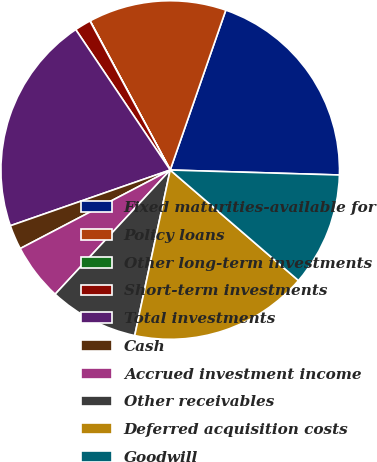Convert chart to OTSL. <chart><loc_0><loc_0><loc_500><loc_500><pie_chart><fcel>Fixed maturities-available for<fcel>Policy loans<fcel>Other long-term investments<fcel>Short-term investments<fcel>Total investments<fcel>Cash<fcel>Accrued investment income<fcel>Other receivables<fcel>Deferred acquisition costs<fcel>Goodwill<nl><fcel>20.14%<fcel>13.17%<fcel>0.02%<fcel>1.56%<fcel>20.91%<fcel>2.34%<fcel>5.43%<fcel>8.53%<fcel>17.04%<fcel>10.85%<nl></chart> 